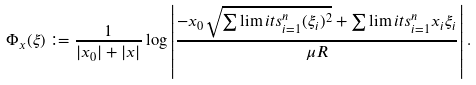Convert formula to latex. <formula><loc_0><loc_0><loc_500><loc_500>\Phi _ { x } ( \xi ) \coloneqq \frac { 1 } { | x _ { 0 } | + | { x } | } \log \left | \frac { - x _ { 0 } \sqrt { \sum \lim i t s _ { i = 1 } ^ { n } ( \xi _ { i } ) ^ { 2 } } + \sum \lim i t s _ { i = 1 } ^ { n } x _ { i } \xi _ { i } } { \mu R } \right | .</formula> 